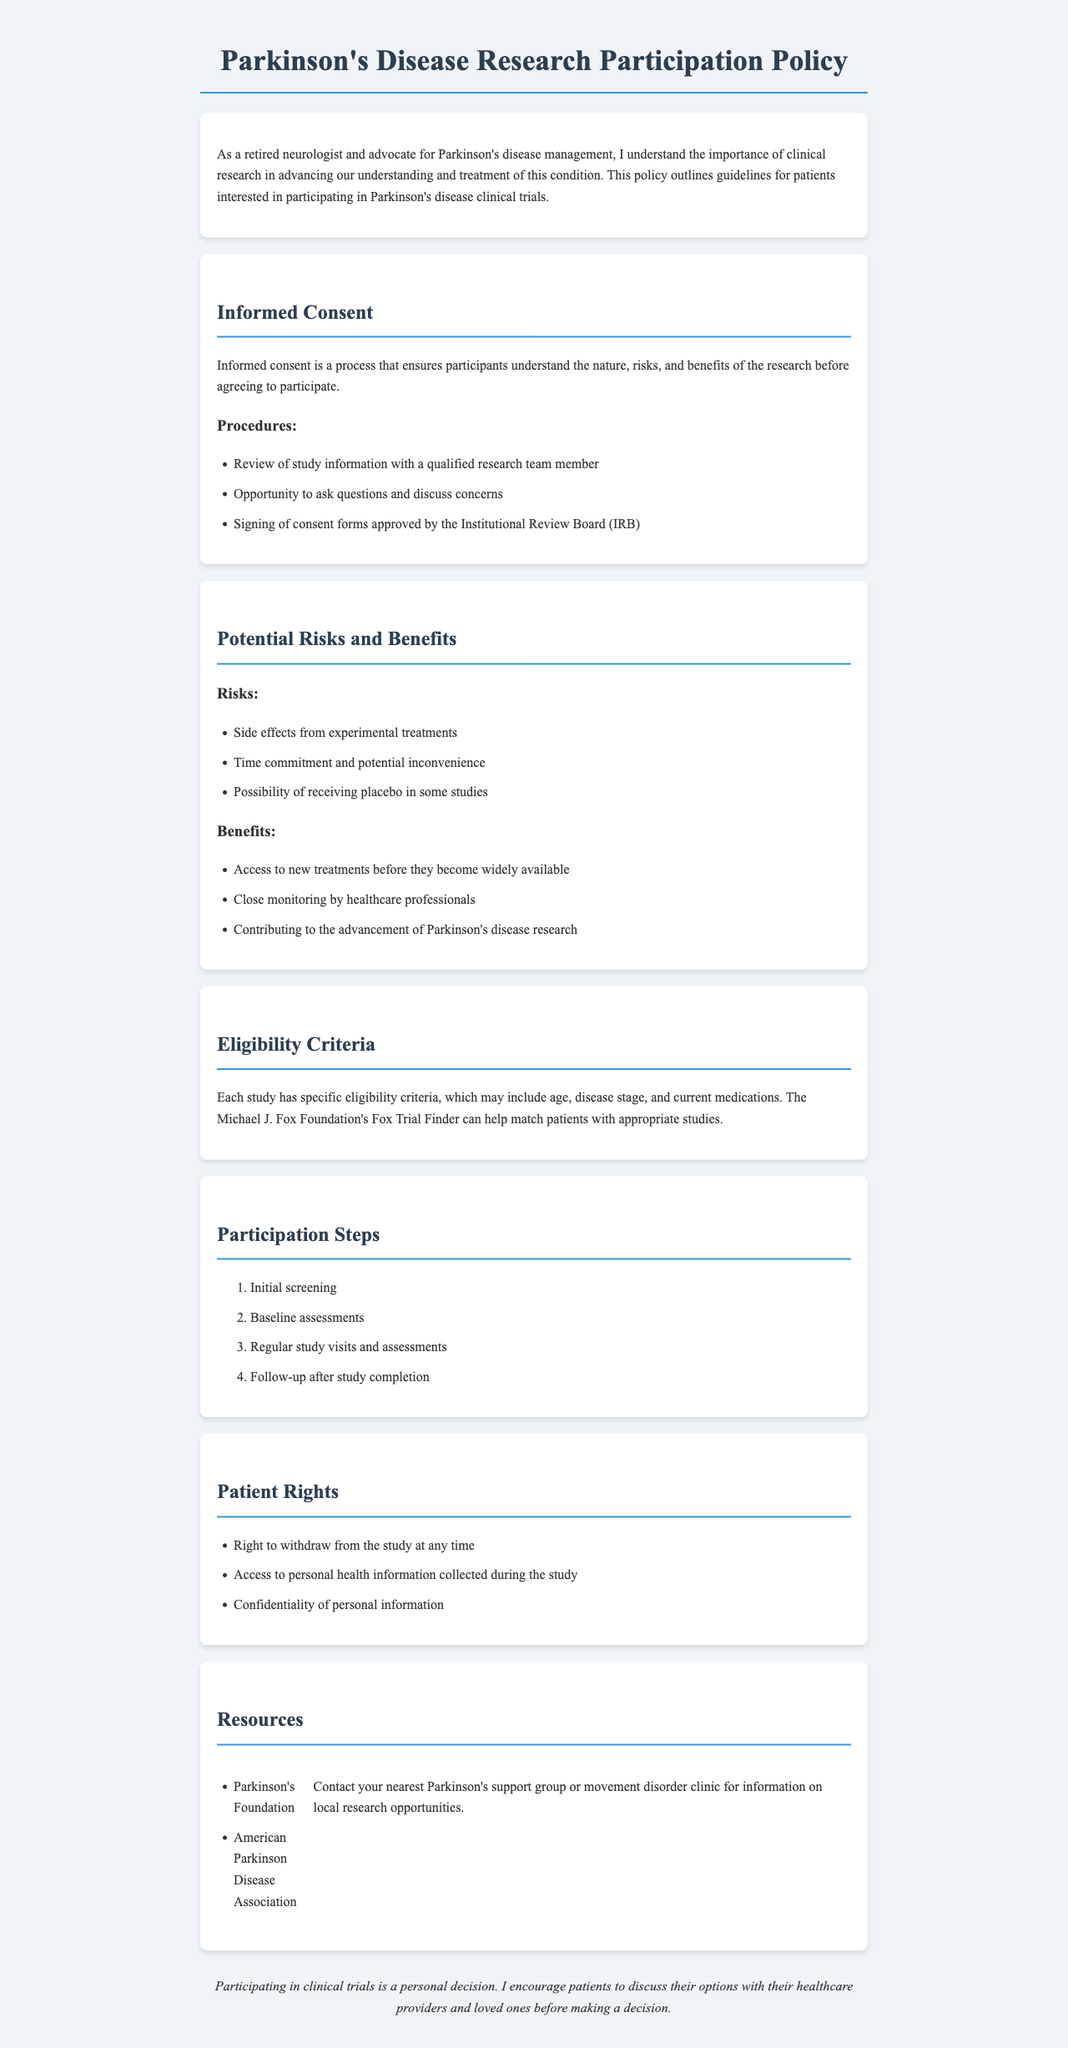What is the title of the document? The title of the document is provided in the heading at the top of the page.
Answer: Parkinson's Disease Research Participation Policy What are one of the risks associated with participation? Risks are listed in a specific section, detailing potential downsides of participation in trials.
Answer: Side effects from experimental treatments What is one of the benefits of participating in clinical trials? Benefits of participation are outlined in a specific section of the document.
Answer: Access to new treatments before they become widely available What is the first step in the participation process? The steps to participation are clearly listed in order, with the first step identified.
Answer: Initial screening Who can help match patients with appropriate studies? The document names a specific foundation that assists with matching patients to studies.
Answer: The Michael J. Fox Foundation's Fox Trial Finder What rights do patients have regarding study withdrawal? Patient rights are detailed in a dedicated section of the document.
Answer: Right to withdraw from the study at any time How many patient rights are listed in the document? The number of patient rights is specified in a list format, and a count can be easily derived.
Answer: Three What is the purpose of informed consent? The document explains the purpose of informed consent in a dedicated section.
Answer: Ensures participants understand the nature, risks, and benefits of the research قبل agreeing to participate What organizations are mentioned as resources? The resources section lists organizations that provide support and information for patients.
Answer: Parkinson's Foundation and American Parkinson Disease Association 